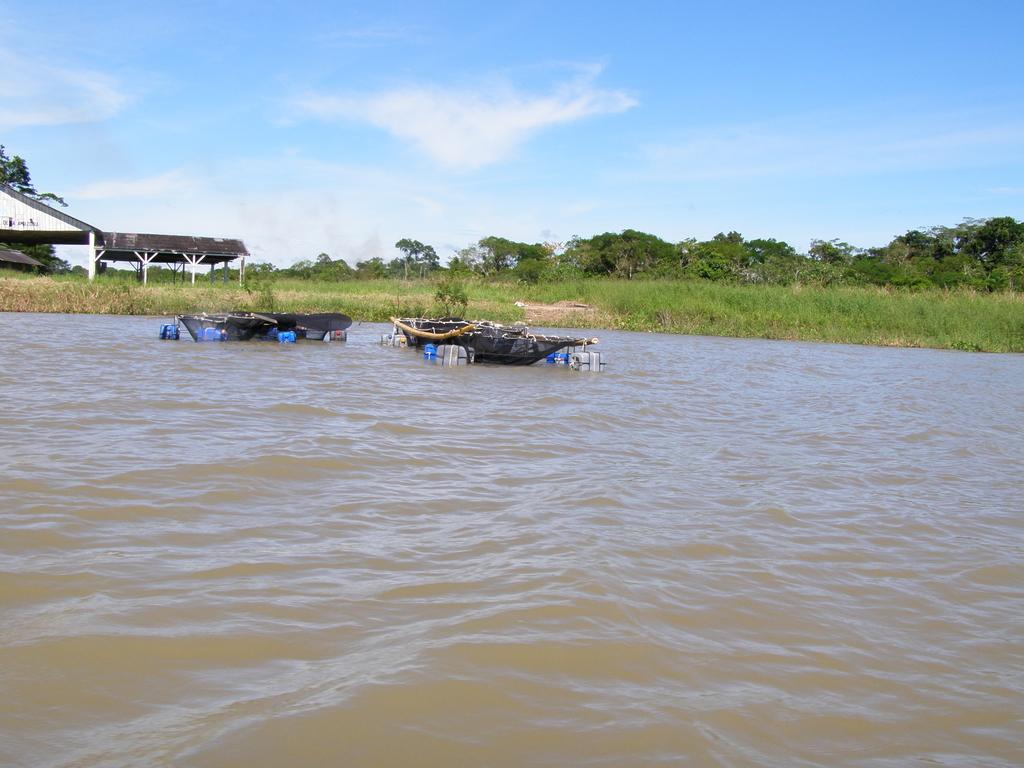How many boats are in the image? There are two boats in the image. Where are the boats located? The boats are on the water. What can be seen in the background of the image? There is a shed and trees in the background of the image. What is the color of the trees? The trees are green. What is visible in the sky in the image? The sky is visible in the image, and it has a combination of white and blue colors. How does the minister sneeze in the image? There is no minister or sneezing in the image; it features two boats on the water with a background of a shed, trees, and sky. 